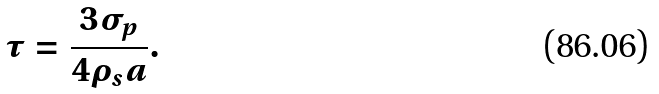Convert formula to latex. <formula><loc_0><loc_0><loc_500><loc_500>\tau = \frac { 3 \sigma _ { p } } { 4 \rho _ { s } a } .</formula> 